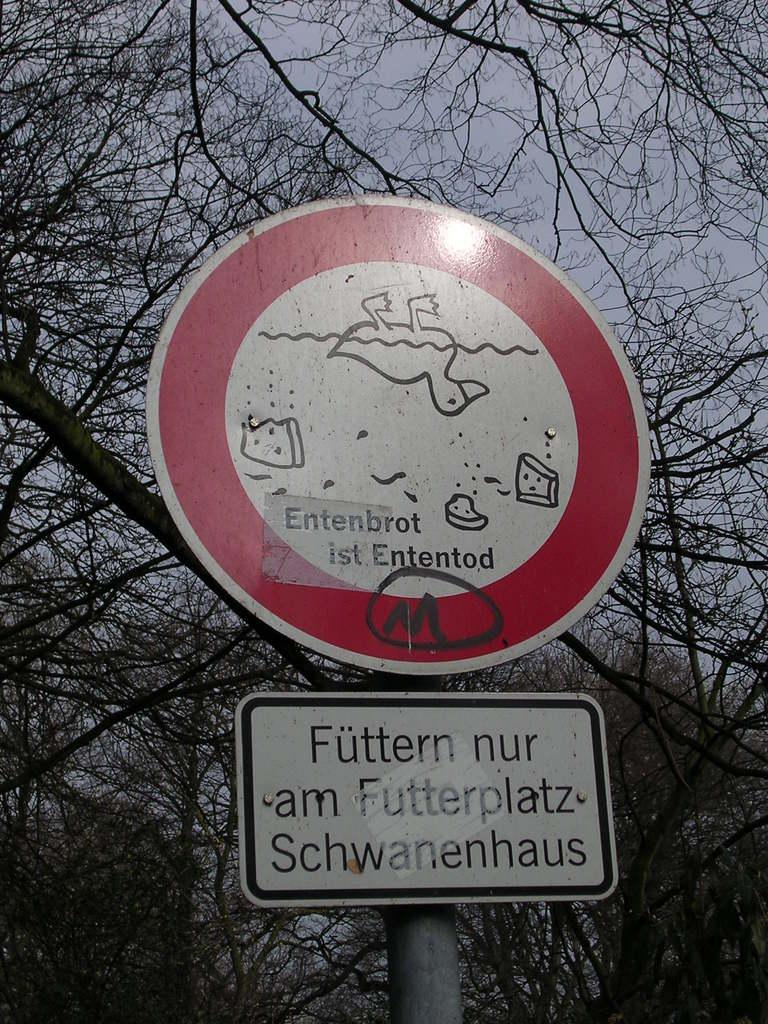What type of vegetation can be seen in the image? There are trees in the image. What is located in the middle of the image? There is a sign board in the middle of the image. How many family members are visible in the image? There are no family members present in the image; it only features trees and a sign board. What type of tank is visible in the image? There is no tank present in the image. 